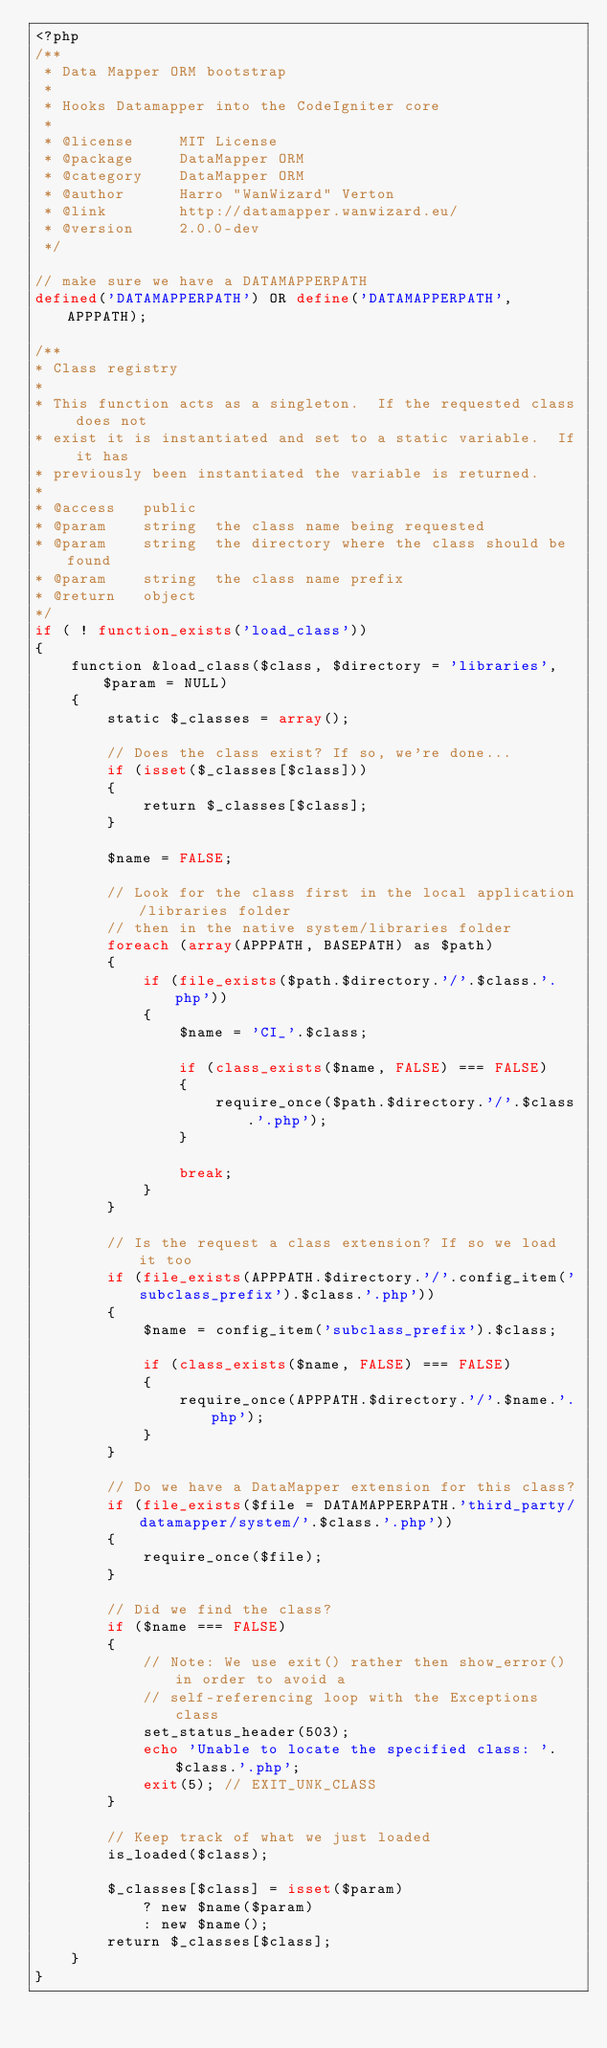Convert code to text. <code><loc_0><loc_0><loc_500><loc_500><_PHP_><?php
/**
 * Data Mapper ORM bootstrap
 *
 * Hooks Datamapper into the CodeIgniter core
 *
 * @license     MIT License
 * @package     DataMapper ORM
 * @category    DataMapper ORM
 * @author      Harro "WanWizard" Verton
 * @link        http://datamapper.wanwizard.eu/
 * @version     2.0.0-dev
 */

// make sure we have a DATAMAPPERPATH
defined('DATAMAPPERPATH') OR define('DATAMAPPERPATH', APPPATH);

/**
* Class registry
*
* This function acts as a singleton.  If the requested class does not
* exist it is instantiated and set to a static variable.  If it has
* previously been instantiated the variable is returned.
*
* @access	public
* @param	string	the class name being requested
* @param	string	the directory where the class should be found
* @param	string	the class name prefix
* @return	object
*/
if ( ! function_exists('load_class'))
{
	function &load_class($class, $directory = 'libraries', $param = NULL)
	{
		static $_classes = array();

		// Does the class exist? If so, we're done...
		if (isset($_classes[$class]))
		{
			return $_classes[$class];
		}

		$name = FALSE;

		// Look for the class first in the local application/libraries folder
		// then in the native system/libraries folder
		foreach (array(APPPATH, BASEPATH) as $path)
		{
			if (file_exists($path.$directory.'/'.$class.'.php'))
			{
				$name = 'CI_'.$class;

				if (class_exists($name, FALSE) === FALSE)
				{
					require_once($path.$directory.'/'.$class.'.php');
				}

				break;
			}
		}

		// Is the request a class extension? If so we load it too
		if (file_exists(APPPATH.$directory.'/'.config_item('subclass_prefix').$class.'.php'))
		{
			$name = config_item('subclass_prefix').$class;

			if (class_exists($name, FALSE) === FALSE)
			{
				require_once(APPPATH.$directory.'/'.$name.'.php');
			}
		}

		// Do we have a DataMapper extension for this class?
		if (file_exists($file = DATAMAPPERPATH.'third_party/datamapper/system/'.$class.'.php'))
		{
			require_once($file);
		}

		// Did we find the class?
		if ($name === FALSE)
		{
			// Note: We use exit() rather then show_error() in order to avoid a
			// self-referencing loop with the Exceptions class
			set_status_header(503);
			echo 'Unable to locate the specified class: '.$class.'.php';
			exit(5); // EXIT_UNK_CLASS
		}

		// Keep track of what we just loaded
		is_loaded($class);

		$_classes[$class] = isset($param)
			? new $name($param)
			: new $name();
		return $_classes[$class];
	}
}
</code> 